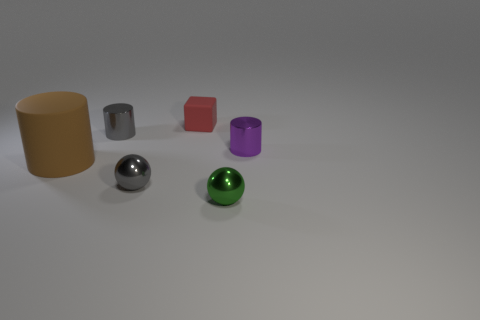Add 4 tiny cylinders. How many objects exist? 10 Subtract all gray cylinders. How many cylinders are left? 2 Subtract all purple cylinders. How many cylinders are left? 2 Subtract all cubes. How many objects are left? 5 Subtract 1 cubes. How many cubes are left? 0 Add 2 tiny red blocks. How many tiny red blocks are left? 3 Add 5 shiny objects. How many shiny objects exist? 9 Subtract 1 gray spheres. How many objects are left? 5 Subtract all brown balls. Subtract all blue cubes. How many balls are left? 2 Subtract all cyan cubes. How many purple balls are left? 0 